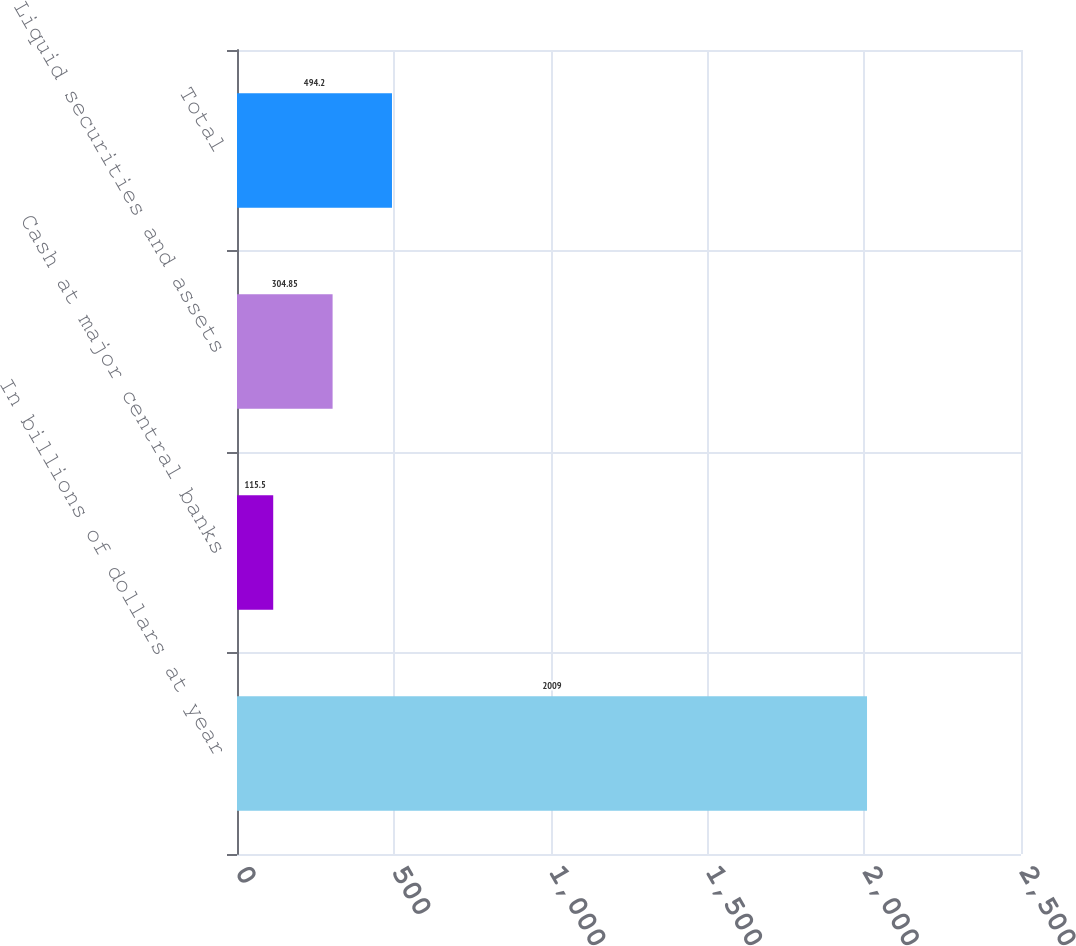Convert chart. <chart><loc_0><loc_0><loc_500><loc_500><bar_chart><fcel>In billions of dollars at year<fcel>Cash at major central banks<fcel>Liquid securities and assets<fcel>Total<nl><fcel>2009<fcel>115.5<fcel>304.85<fcel>494.2<nl></chart> 